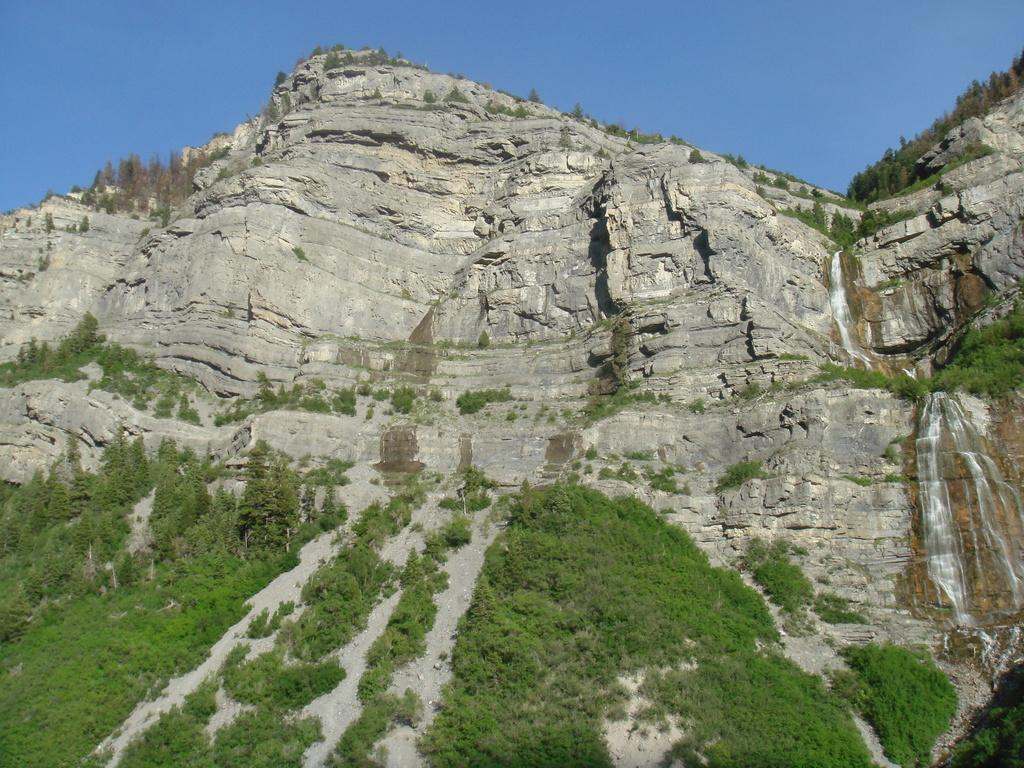What type of natural landscape can be seen in the image? There are hills in the image. What specific feature can be found among the hills? There is a waterfall in the image. What type of vegetation is present in the image? There are trees in the image. What part of the natural environment is visible in the image? The sky is visible in the image. How many ants can be seen climbing the waterfall in the image? There are no ants present in the image, and therefore no such activity can be observed. What type of ship is visible sailing in the sky in the image? There is no ship visible in the sky in the image. 